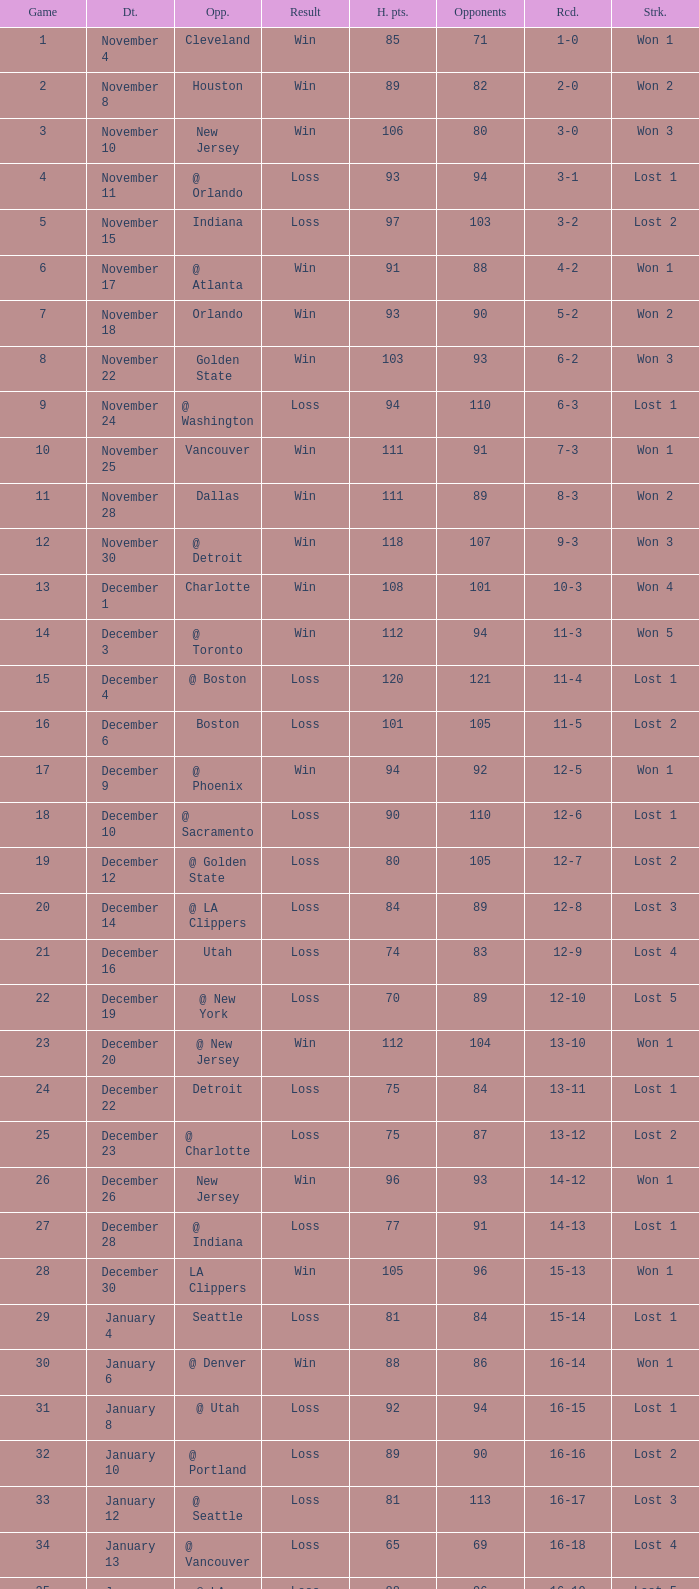What is Heat Points, when Game is less than 80, and when Date is "April 26 (First Round)"? 85.0. 